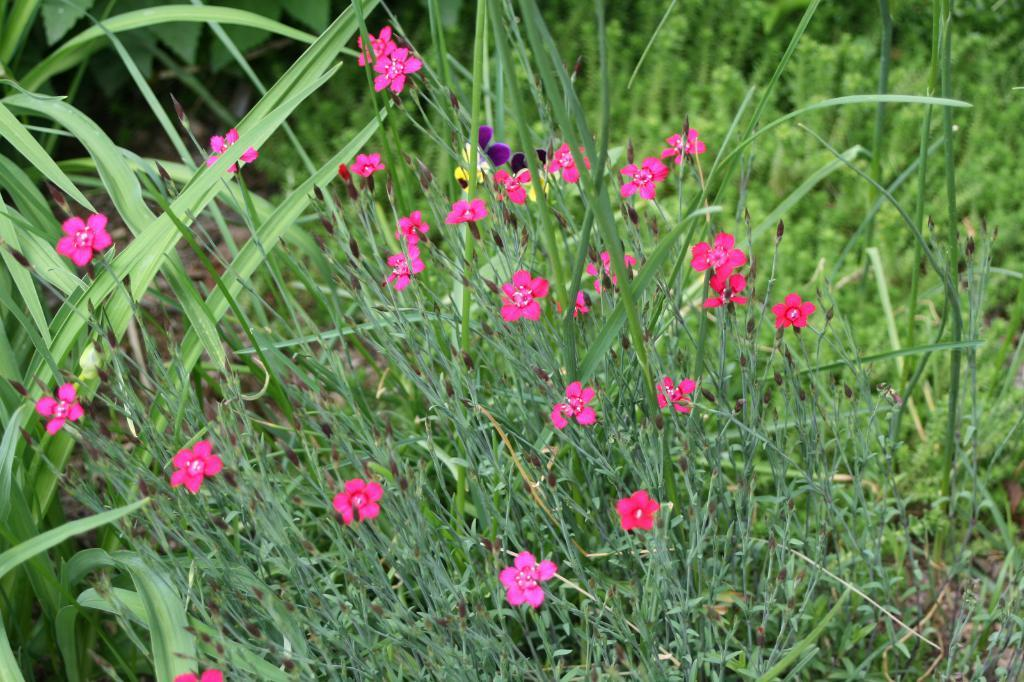What type of plants can be seen in the picture? There are flower plants in the picture. What color are the flowers on the plants? The flowers are pink in color. What type of hair can be seen on the office desk in the image? There is no hair or office desk present in the image; it features flower plants with pink flowers. 